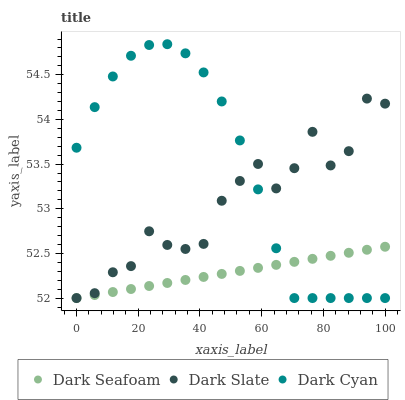Does Dark Seafoam have the minimum area under the curve?
Answer yes or no. Yes. Does Dark Cyan have the maximum area under the curve?
Answer yes or no. Yes. Does Dark Slate have the minimum area under the curve?
Answer yes or no. No. Does Dark Slate have the maximum area under the curve?
Answer yes or no. No. Is Dark Seafoam the smoothest?
Answer yes or no. Yes. Is Dark Slate the roughest?
Answer yes or no. Yes. Is Dark Slate the smoothest?
Answer yes or no. No. Is Dark Seafoam the roughest?
Answer yes or no. No. Does Dark Cyan have the lowest value?
Answer yes or no. Yes. Does Dark Cyan have the highest value?
Answer yes or no. Yes. Does Dark Slate have the highest value?
Answer yes or no. No. Does Dark Seafoam intersect Dark Slate?
Answer yes or no. Yes. Is Dark Seafoam less than Dark Slate?
Answer yes or no. No. Is Dark Seafoam greater than Dark Slate?
Answer yes or no. No. 